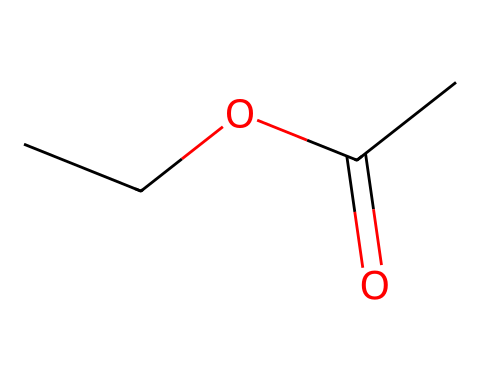What is the molecular formula of ethyl acetate? To find the molecular formula, we can count the number of each type of atom in the chemical structure represented by the SMILES. From the SMILES, we see that there are 4 carbon atoms (C), 8 hydrogen atoms (H), and 2 oxygen atoms (O). Thus, the molecular formula is C4H8O2.
Answer: C4H8O2 How many total atoms are present in ethyl acetate? The total number of atoms can be calculated by adding the number of each type of atom together. From the molecular formula C4H8O2, we have 4 carbon atoms, 8 hydrogen atoms, and 2 oxygen atoms. Therefore, 4 + 8 + 2 gives a total of 14 atoms.
Answer: 14 What is the functional group present in ethyl acetate? The SMILES indicates the presence of an ester functional group, which is characterized by the -COO- segment in its structure. This matches the ester group definition, confirming that ethyl acetate is an ester.
Answer: ester How many double bonds are in ethyl acetate? By analyzing the SMILES and the resulting molecular structure, we notice that there is one double bond present in the carbonyl group (C=O) in the acetate part of the molecule. Therefore, there is 1 double bond.
Answer: 1 What properties does the ester functional group imply for ethyl acetate? The ester functional group typically imparts fruity aromas and is responsible for many flavors. This suggests that ethyl acetate will have a characteristic pleasant smell and is commonly used in flavors and fragrances.
Answer: fruity aroma Does ethyl acetate participate in hydrogen bonding? Ethyl acetate does not participate in hydrogen bonding as an acceptor or donor due to the absence of highly electronegative atoms bonded to hydrogen in the structure. The only oxygen is part of the carbonyl and ester bond, which does not contribute to strong hydrogen bonding interactions.
Answer: no 